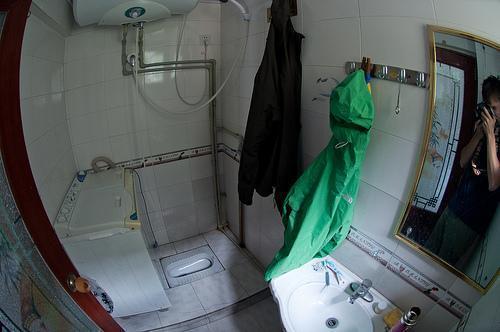How many people are in the pic?
Give a very brief answer. 1. 